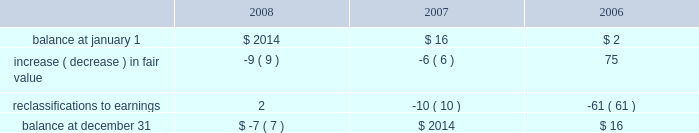Stockholders 2019 equity derivative instruments activity , net of tax , included in non-owner changes to equity within the consolidated statements of stockholders 2019 equity for the years ended december 31 , 2008 , 2007 and 2006 is as follows: .
Net investment in foreign operations hedge at december 31 , 2008 and 2007 , the company did not have any hedges of foreign currency exposure of net investments in foreign operations .
Investments hedge during the first quarter of 2006 , the company entered into a zero-cost collar derivative ( the 201csprint nextel derivative 201d ) to protect itself economically against price fluctuations in its 37.6 million shares of sprint nextel corporation ( 201csprint nextel 201d ) non-voting common stock .
During the second quarter of 2006 , as a result of sprint nextel 2019s spin-off of embarq corporation through a dividend to sprint nextel shareholders , the company received approximately 1.9 million shares of embarq corporation .
The floor and ceiling prices of the sprint nextel derivative were adjusted accordingly .
The sprint nextel derivative was not designated as a hedge under the provisions of sfas no .
133 , 201caccounting for derivative instruments and hedging activities . 201d accordingly , to reflect the change in fair value of the sprint nextel derivative , the company recorded a net gain of $ 99 million for the year ended december 31 , 2006 , included in other income ( expense ) in the company 2019s consolidated statements of operations .
In december 2006 , the sprint nextel derivative was terminated and settled in cash and the 37.6 million shares of sprint nextel were converted to common shares and sold .
The company received aggregate cash proceeds of approximately $ 820 million from the settlement of the sprint nextel derivative and the subsequent sale of the 37.6 million sprint nextel shares .
The company recognized a loss of $ 126 million in connection with the sale of the remaining shares of sprint nextel common stock .
As described above , the company recorded a net gain of $ 99 million in connection with the sprint nextel derivative .
Fair value of financial instruments the company 2019s financial instruments include cash equivalents , sigma fund investments , short-term investments , accounts receivable , long-term receivables , accounts payable , accrued liabilities , derivatives and other financing commitments .
The company 2019s sigma fund , available-for-sale investment portfolios and derivatives are recorded in the company 2019s consolidated balance sheets at fair value .
All other financial instruments , with the exception of long-term debt , are carried at cost , which is not materially different than the instruments 2019 fair values .
Using quoted market prices and market interest rates , the company determined that the fair value of long- term debt at december 31 , 2008 was $ 2.8 billion , compared to a carrying value of $ 4.1 billion .
Since considerable judgment is required in interpreting market information , the fair value of the long-term debt is not necessarily indicative of the amount which could be realized in a current market exchange .
Equity price market risk at december 31 , 2008 , the company 2019s available-for-sale equity securities portfolio had an approximate fair market value of $ 128 million , which represented a cost basis of $ 125 million and a net unrealized loss of $ 3 million .
These equity securities are held for purposes other than trading .
%%transmsg*** transmitting job : c49054 pcn : 105000000 ***%%pcmsg|102 |00022|yes|no|02/23/2009 19:17|0|0|page is valid , no graphics -- color : n| .
What is the percent change in total balance of stockholder equity between january 2006 and 2007? 
Computations: ((16 - 2) / 2)
Answer: 7.0. 